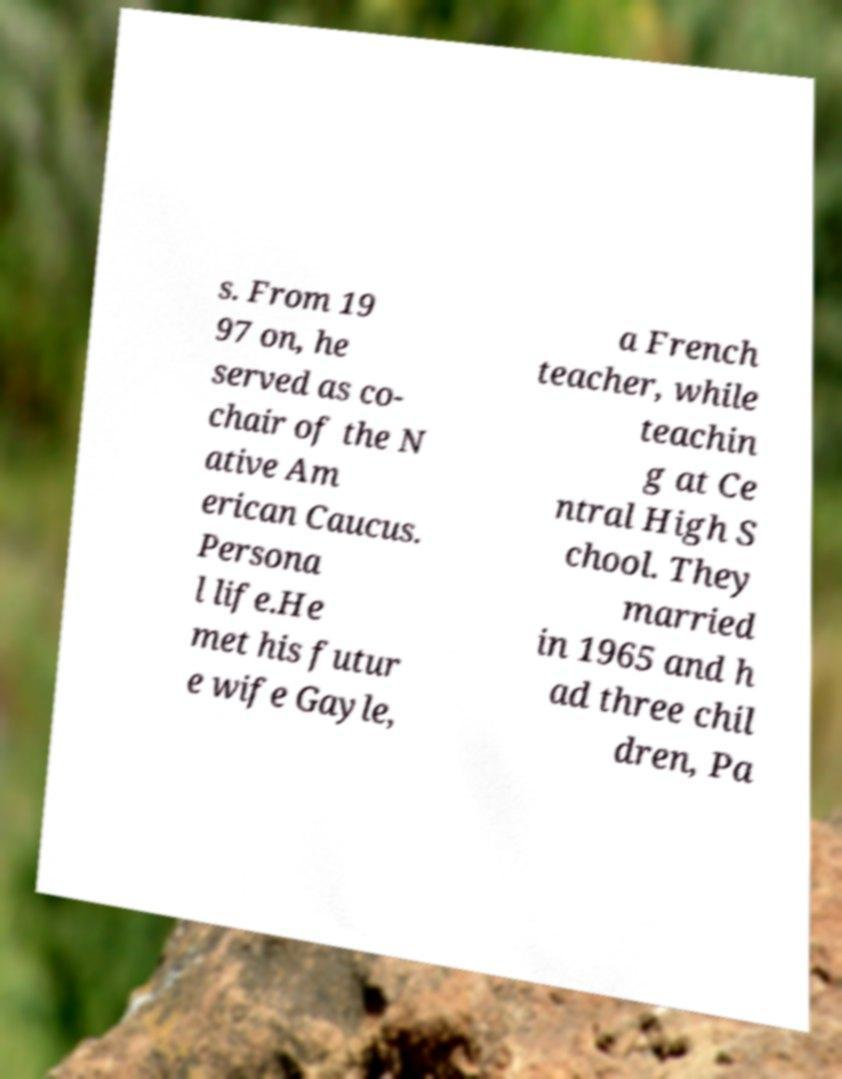There's text embedded in this image that I need extracted. Can you transcribe it verbatim? s. From 19 97 on, he served as co- chair of the N ative Am erican Caucus. Persona l life.He met his futur e wife Gayle, a French teacher, while teachin g at Ce ntral High S chool. They married in 1965 and h ad three chil dren, Pa 